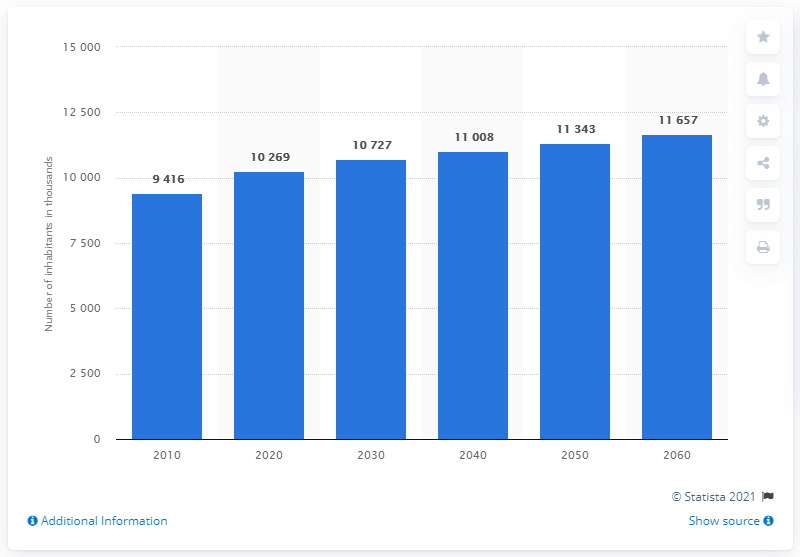Identify some key points in this picture. It is projected that by 2060, the population of Sweden will be approximately 116,571 people. 